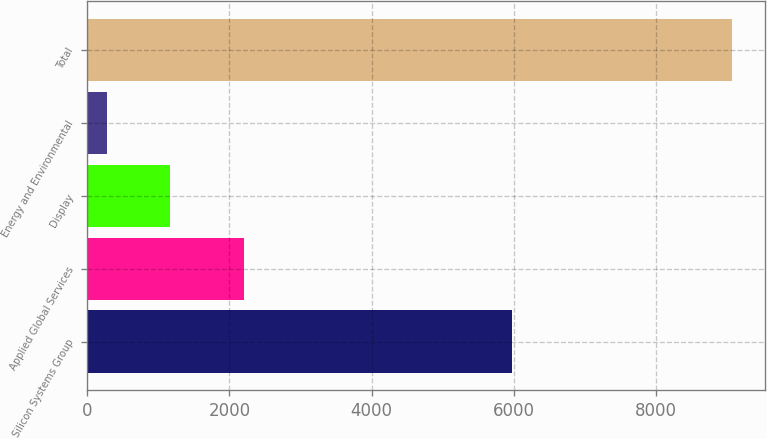Convert chart to OTSL. <chart><loc_0><loc_0><loc_500><loc_500><bar_chart><fcel>Silicon Systems Group<fcel>Applied Global Services<fcel>Display<fcel>Energy and Environmental<fcel>Total<nl><fcel>5978<fcel>2200<fcel>1158.3<fcel>279<fcel>9072<nl></chart> 